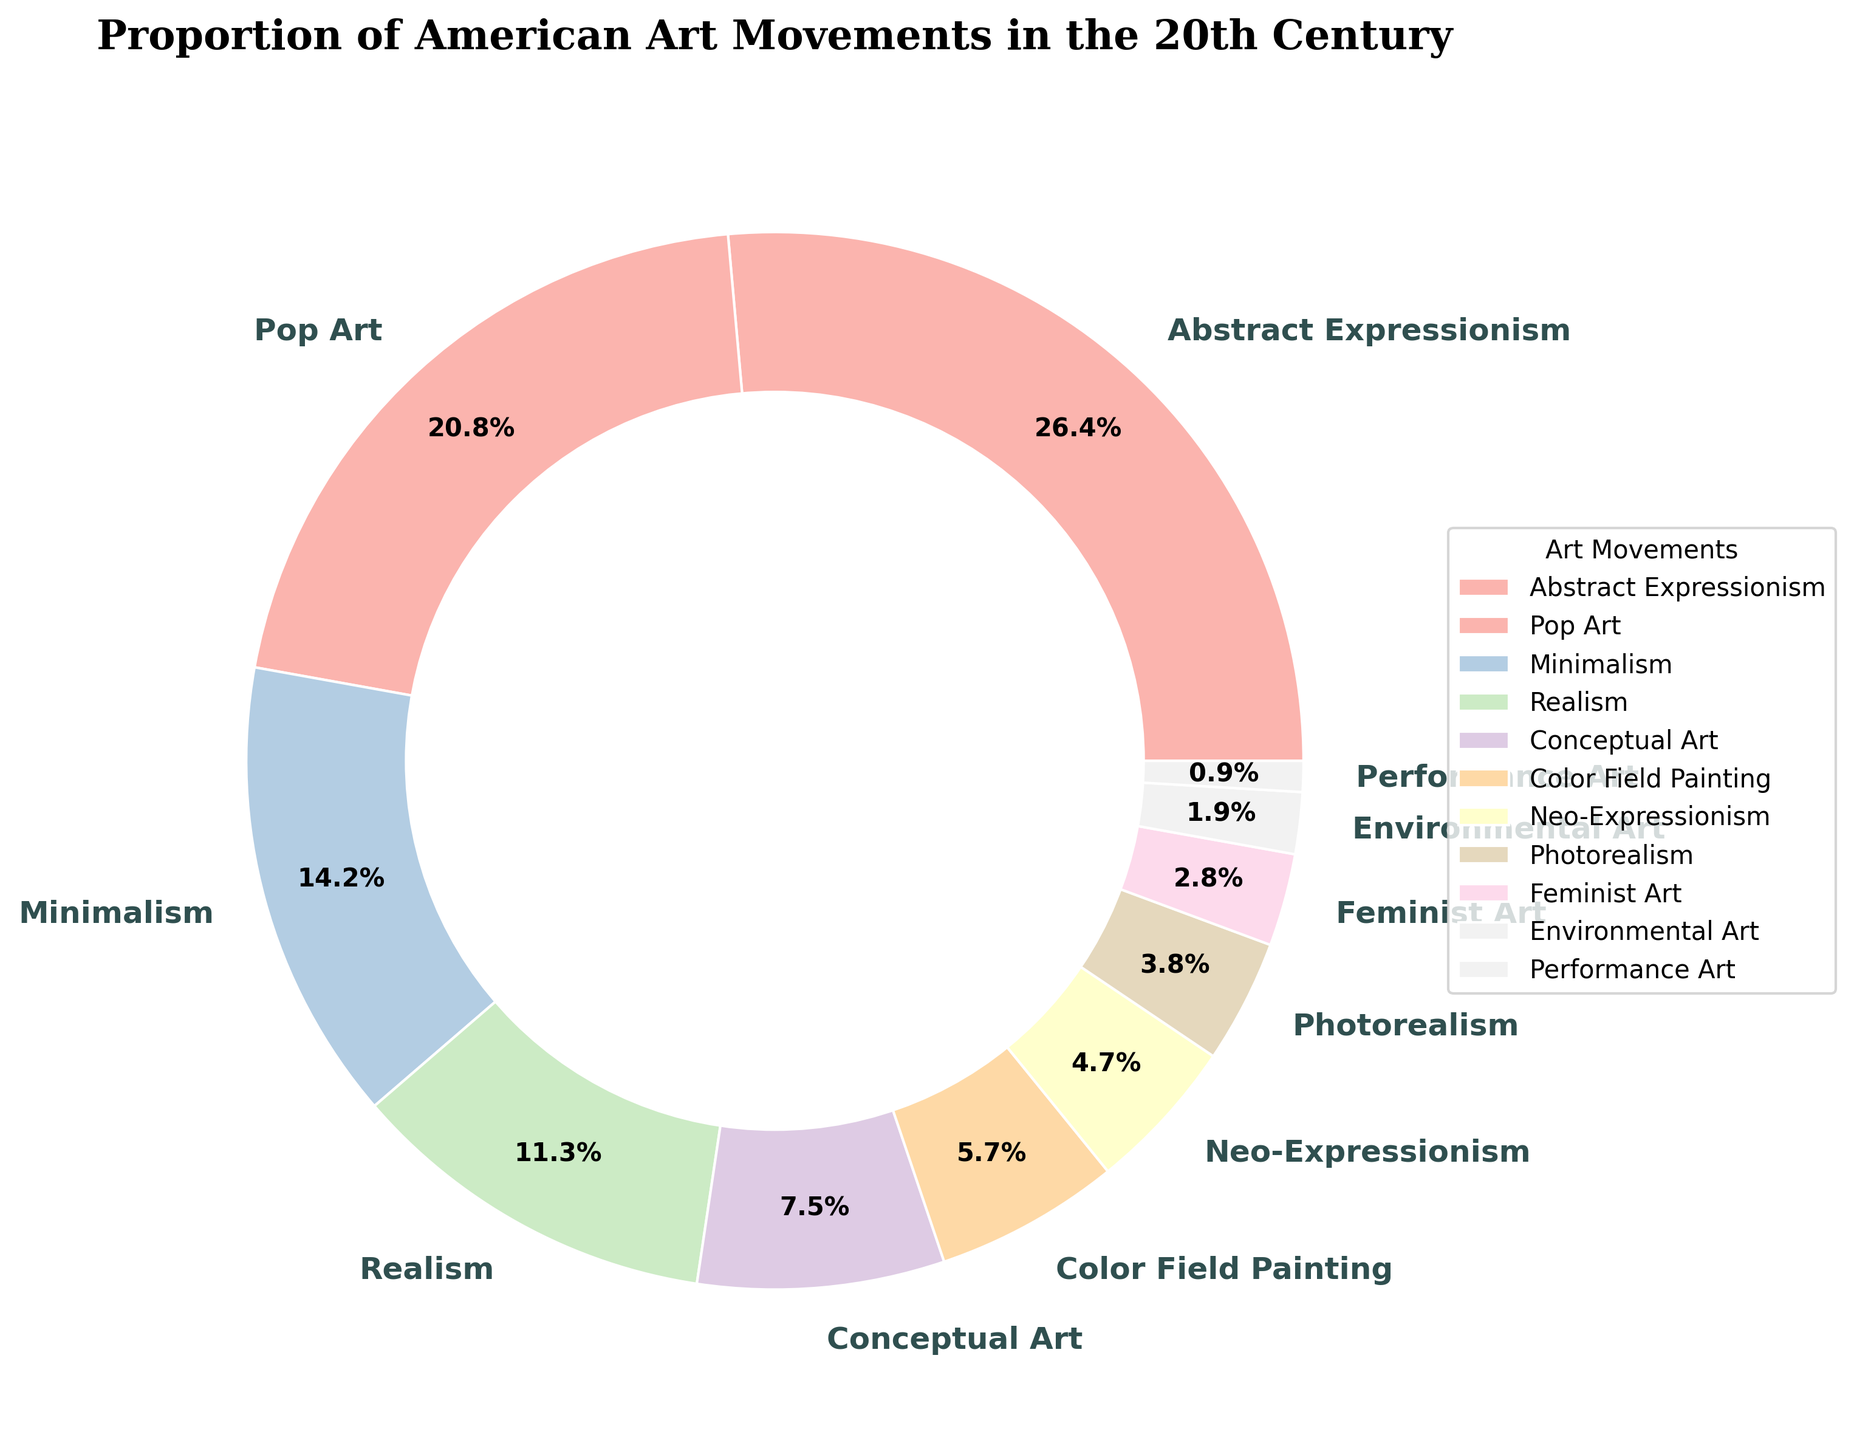Which art movement has the highest proportion in the pie chart? The pie chart shows the proportion of various American art movements in the 20th century. Abstract Expressionism has the highest proportion, occupying 28% of the chart.
Answer: Abstract Expressionism How much of the total percentage do Pop Art and Minimalism together represent? To find the combined percentage of Pop Art and Minimalism, add their individual percentages: Pop Art (22%) + Minimalism (15%) = 37%.
Answer: 37% Which art movement has a smaller proportion, Realism or Conceptual Art? The pie chart indicates that Realism has 12% and Conceptual Art has 8%. Comparing the two, Conceptual Art has the smaller proportion.
Answer: Conceptual Art What percentage of the chart is made up of movements with a proportion of 5% or less? Add the percentages of movements with 5% or less: Neo-Expressionism (5%) + Photorealism (4%) + Feminist Art (3%) + Environmental Art (2%) + Performance Art (1%) = 5 + 4 + 3 + 2 + 1 = 15%.
Answer: 15% Which movements are represented using colors other than shades in a pie chart? In the pie chart, different movements are represented with various pastel shades. For example, Abstract Expressionism is one color, Pop Art is another, and so on. All movements are represented using distinct colors.
Answer: All movements How does the proportion of Feminist Art compare to that of Environmental Art? The pie chart shows that Feminist Art makes up 3% while Environmental Art makes up 2%. Thus, Feminist Art has a higher proportion compared to Environmental Art.
Answer: Feminist Art What is the difference in percentage between Color Field Painting and Neo-Expressionism? The percentages are Color Field Painting (6%) and Neo-Expressionism (5%). Subtract Neo-Expressionism's percentage from Color Field Painting's: 6% - 5% = 1%.
Answer: 1% If the total percentage of all listed art movements is 100%, what is the combined percentage of movements not listed in the chart? Since every significant movement is accounted for and the total percentage of all listed movements sums to 100%, the percentage of movements not listed in the chart is 0%.
Answer: 0% Which movement occupies more space on the chart, Conceptual Art or Color Field Painting? According to the chart, Conceptual Art occupies 8%, while Color Field Painting occupies 6%. Therefore, Conceptual Art takes up more space on the chart.
Answer: Conceptual Art 